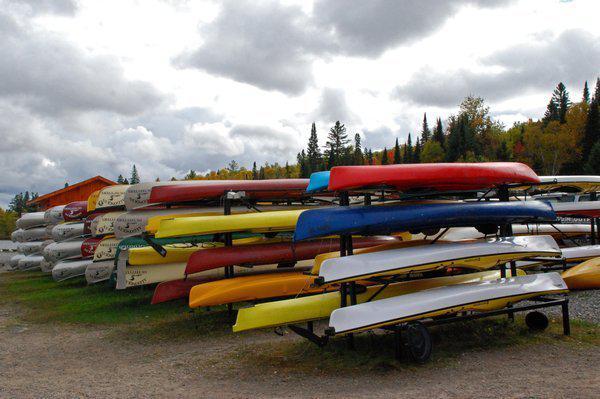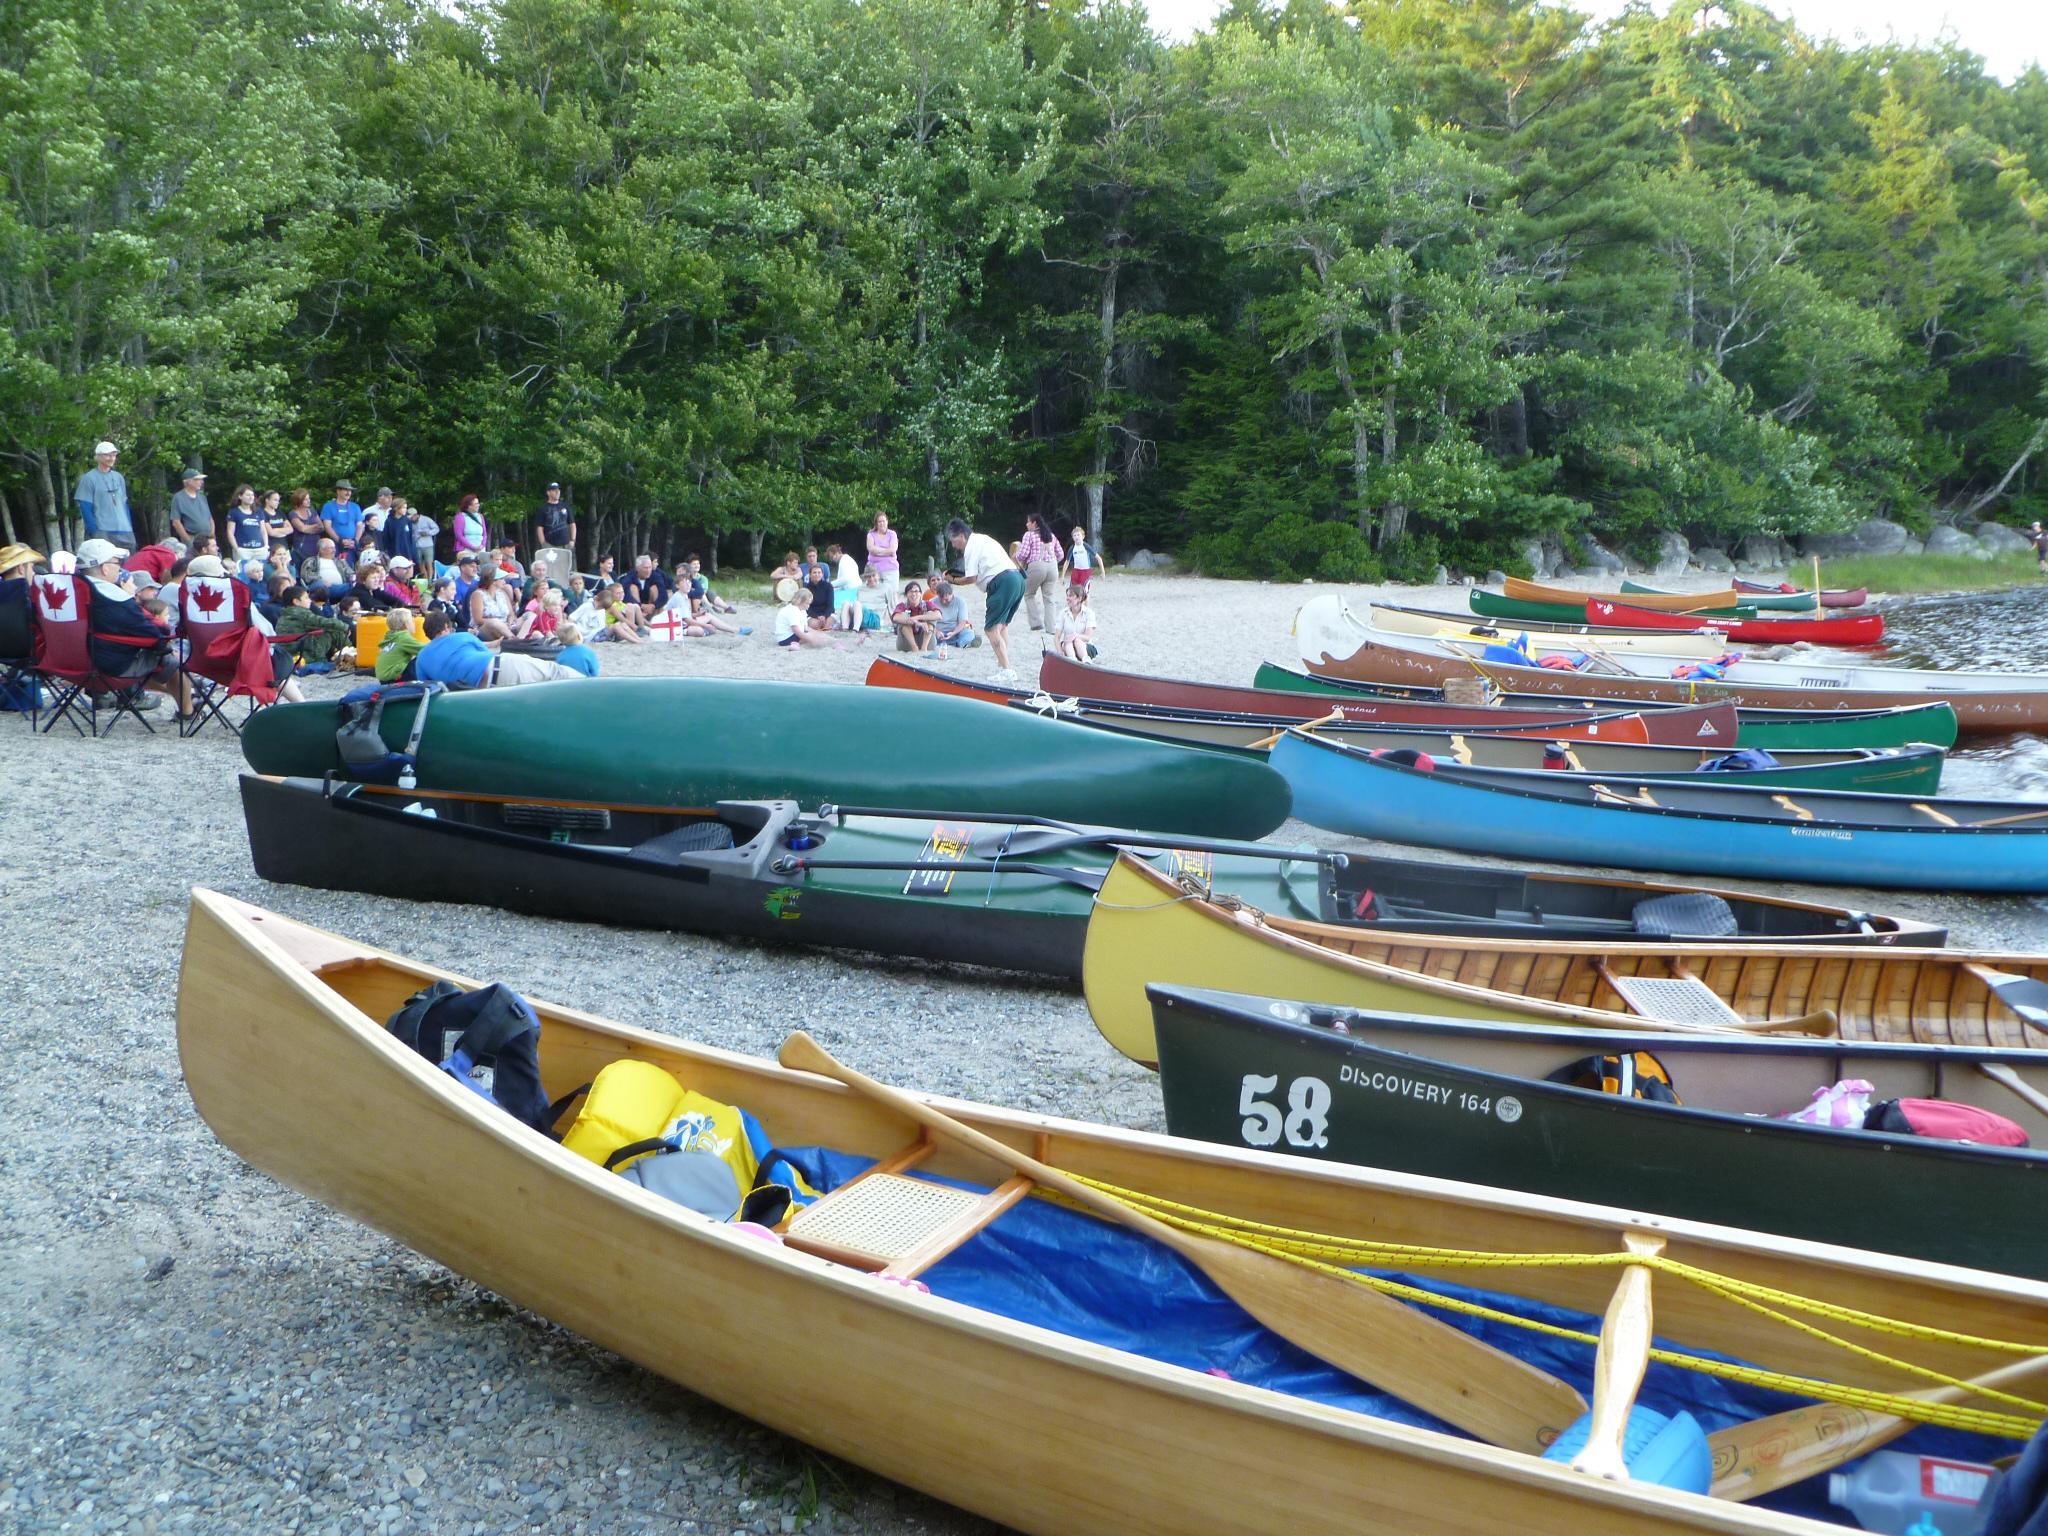The first image is the image on the left, the second image is the image on the right. For the images shown, is this caption "There is more than one boat in the image on the right." true? Answer yes or no. Yes. 